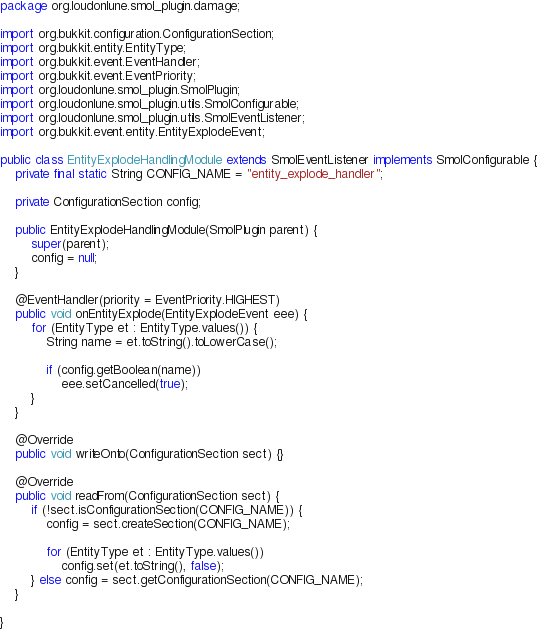<code> <loc_0><loc_0><loc_500><loc_500><_Java_>package org.loudonlune.smol_plugin.damage;

import org.bukkit.configuration.ConfigurationSection;
import org.bukkit.entity.EntityType;
import org.bukkit.event.EventHandler;
import org.bukkit.event.EventPriority;
import org.loudonlune.smol_plugin.SmolPlugin;
import org.loudonlune.smol_plugin.utils.SmolConfigurable;
import org.loudonlune.smol_plugin.utils.SmolEventListener;
import org.bukkit.event.entity.EntityExplodeEvent;

public class EntityExplodeHandlingModule extends SmolEventListener implements SmolConfigurable {
	private final static String CONFIG_NAME = "entity_explode_handler";
	
	private ConfigurationSection config;
	
	public EntityExplodeHandlingModule(SmolPlugin parent) {
		super(parent);
		config = null;
	}
	
	@EventHandler(priority = EventPriority.HIGHEST)
	public void onEntityExplode(EntityExplodeEvent eee) {
		for (EntityType et : EntityType.values()) {
			String name = et.toString().toLowerCase();
			
			if (config.getBoolean(name))
				eee.setCancelled(true);
		}
	}

	@Override
	public void writeOnto(ConfigurationSection sect) {}

	@Override
	public void readFrom(ConfigurationSection sect) {
		if (!sect.isConfigurationSection(CONFIG_NAME)) {
			config = sect.createSection(CONFIG_NAME);
			
			for (EntityType et : EntityType.values())
				config.set(et.toString(), false);
		} else config = sect.getConfigurationSection(CONFIG_NAME);
	}
	
}
</code> 